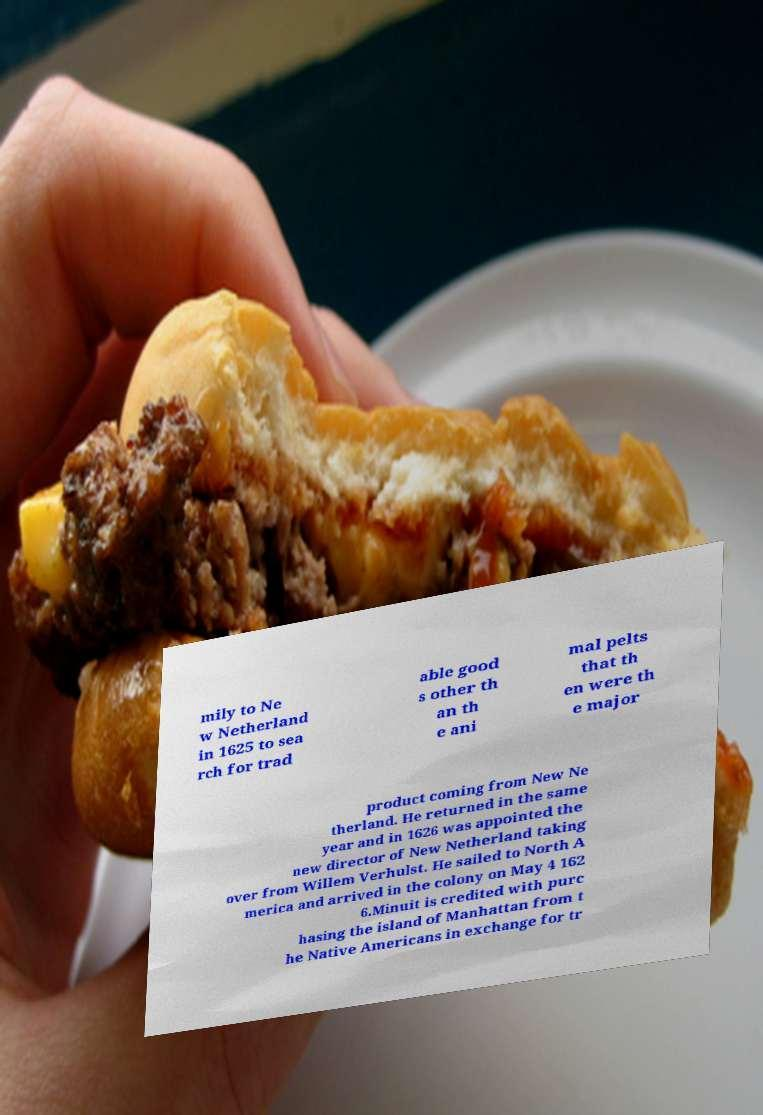Can you accurately transcribe the text from the provided image for me? mily to Ne w Netherland in 1625 to sea rch for trad able good s other th an th e ani mal pelts that th en were th e major product coming from New Ne therland. He returned in the same year and in 1626 was appointed the new director of New Netherland taking over from Willem Verhulst. He sailed to North A merica and arrived in the colony on May 4 162 6.Minuit is credited with purc hasing the island of Manhattan from t he Native Americans in exchange for tr 